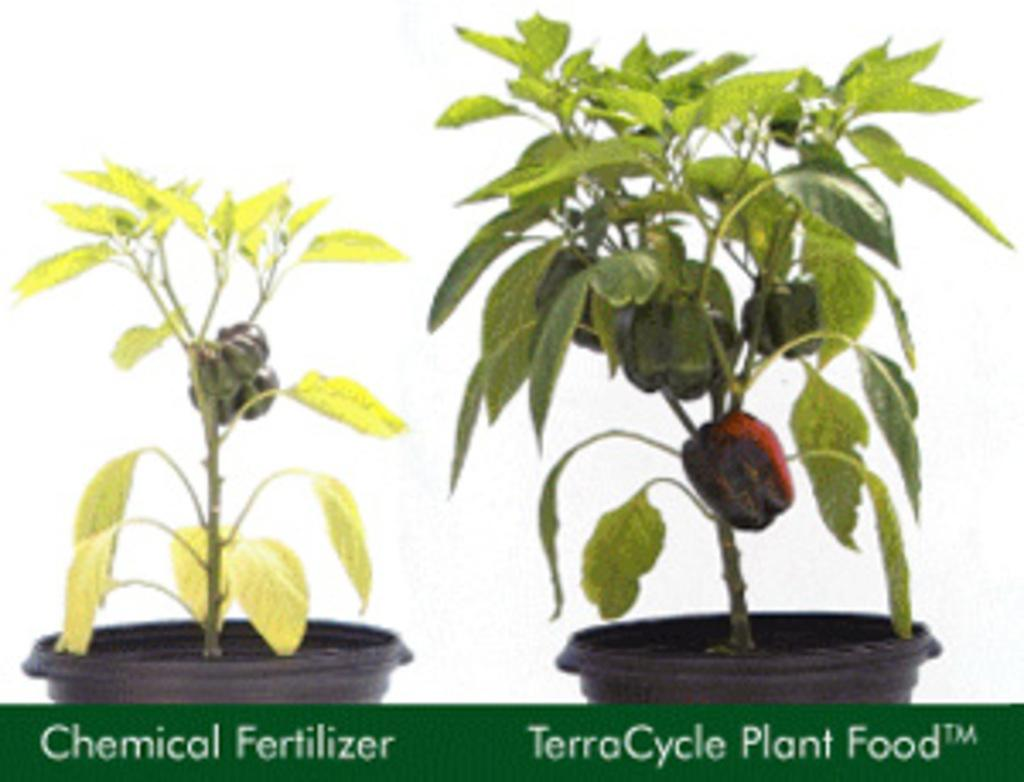How many plants are in the image? There are two plants in the image. What else can be seen in the image besides the plants? There are vegetables visible in the image. Is there any text present in the image? Yes, there is text visible in the image. What type of ship can be seen in the image? There is no ship present in the image. Is there a rifle visible in the image? There is no rifle present in the image. 